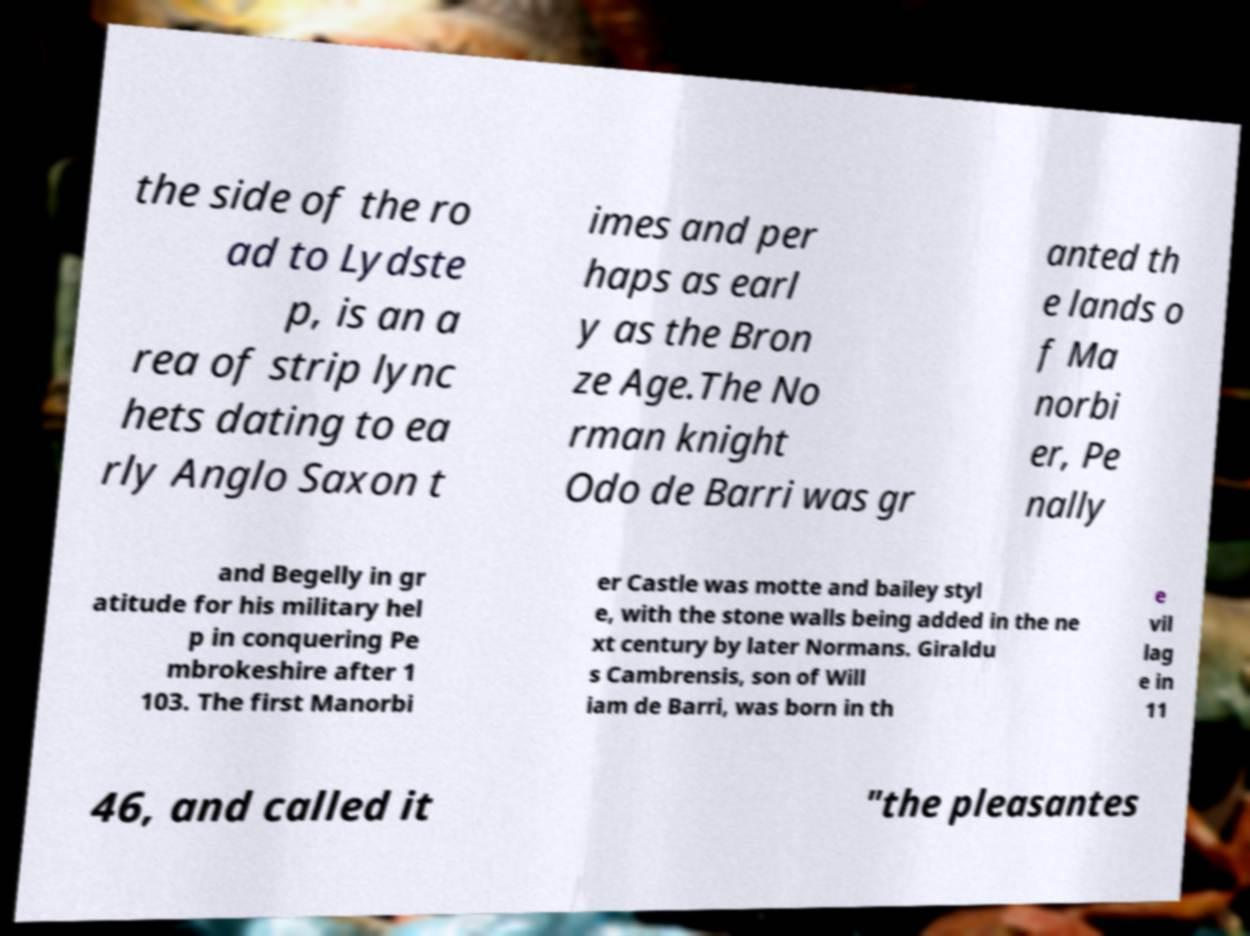For documentation purposes, I need the text within this image transcribed. Could you provide that? the side of the ro ad to Lydste p, is an a rea of strip lync hets dating to ea rly Anglo Saxon t imes and per haps as earl y as the Bron ze Age.The No rman knight Odo de Barri was gr anted th e lands o f Ma norbi er, Pe nally and Begelly in gr atitude for his military hel p in conquering Pe mbrokeshire after 1 103. The first Manorbi er Castle was motte and bailey styl e, with the stone walls being added in the ne xt century by later Normans. Giraldu s Cambrensis, son of Will iam de Barri, was born in th e vil lag e in 11 46, and called it "the pleasantes 